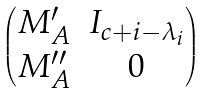Convert formula to latex. <formula><loc_0><loc_0><loc_500><loc_500>\begin{pmatrix} M ^ { \prime } _ { A } & I _ { c + i - \lambda _ { i } } \\ M ^ { \prime \prime } _ { A } & 0 \end{pmatrix}</formula> 